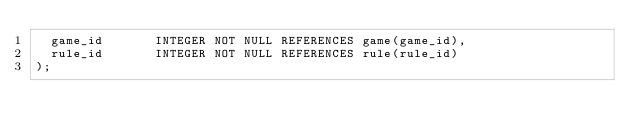<code> <loc_0><loc_0><loc_500><loc_500><_SQL_>  game_id       INTEGER NOT NULL REFERENCES game(game_id),
  rule_id       INTEGER NOT NULL REFERENCES rule(rule_id)
);
</code> 